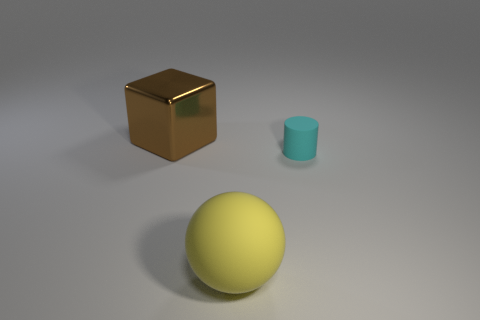Is there anything else that is the same shape as the big metal object?
Provide a succinct answer. No. What is the color of the large object to the left of the big object in front of the large brown shiny object?
Make the answer very short. Brown. What number of purple spheres are there?
Your answer should be compact. 0. What number of matte things are either large yellow spheres or red cylinders?
Give a very brief answer. 1. How many metal cubes have the same color as the large ball?
Your response must be concise. 0. There is a thing that is on the left side of the large object that is in front of the cyan rubber cylinder; what is it made of?
Provide a short and direct response. Metal. The yellow thing is what size?
Ensure brevity in your answer.  Large. How many other brown cubes have the same size as the brown block?
Your answer should be very brief. 0. How many big rubber things are the same shape as the small thing?
Ensure brevity in your answer.  0. Are there an equal number of metallic objects left of the big matte thing and tiny cyan matte objects?
Provide a short and direct response. Yes. 